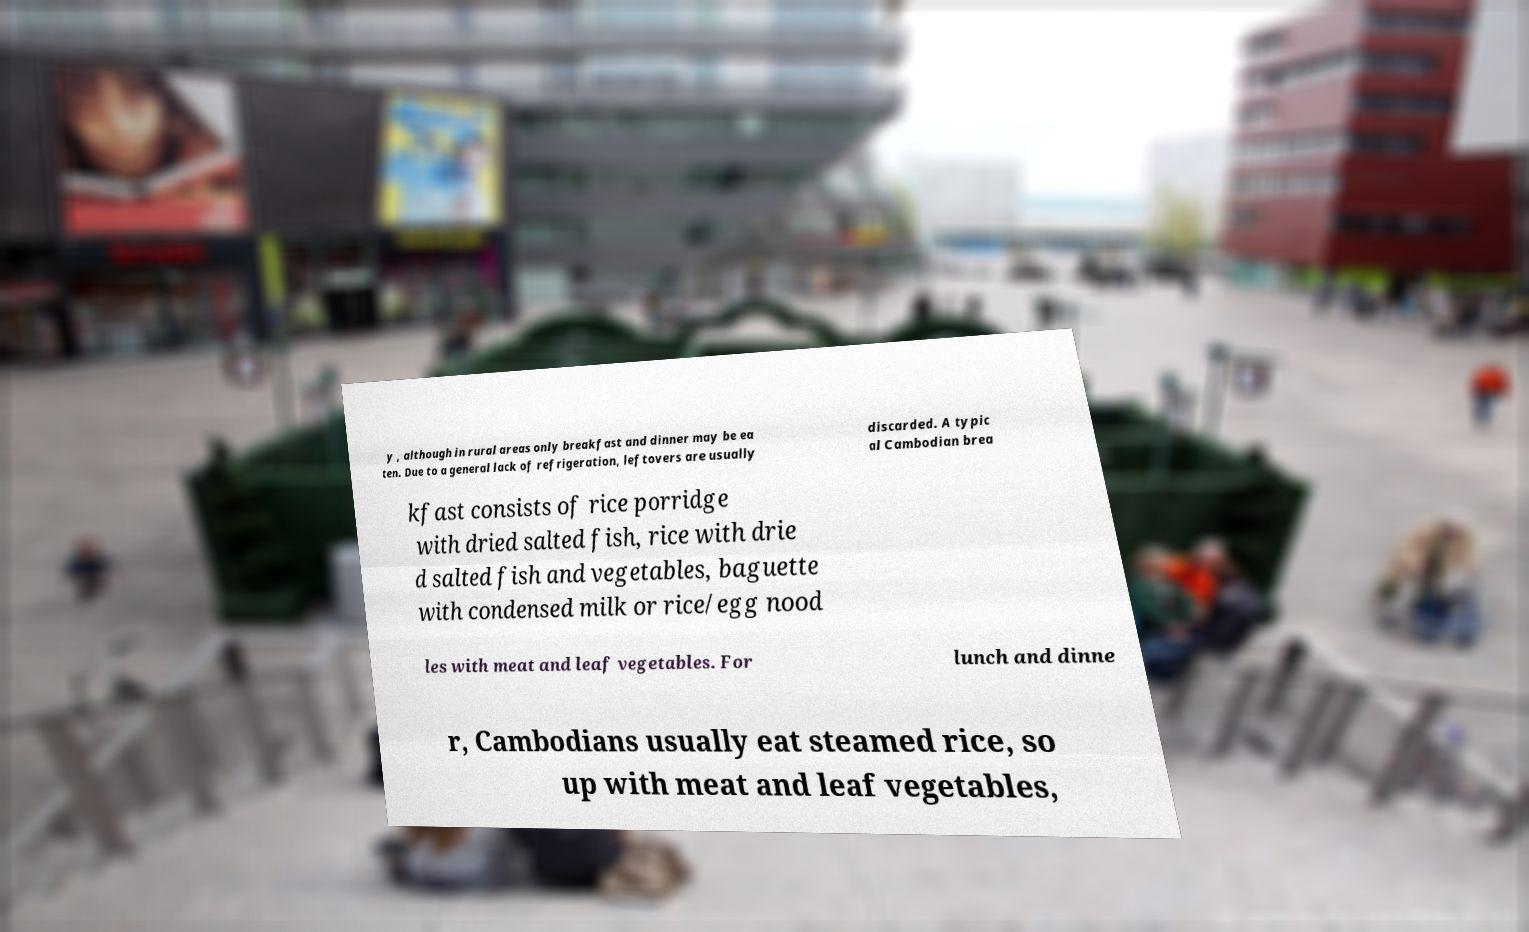What messages or text are displayed in this image? I need them in a readable, typed format. y , although in rural areas only breakfast and dinner may be ea ten. Due to a general lack of refrigeration, leftovers are usually discarded. A typic al Cambodian brea kfast consists of rice porridge with dried salted fish, rice with drie d salted fish and vegetables, baguette with condensed milk or rice/egg nood les with meat and leaf vegetables. For lunch and dinne r, Cambodians usually eat steamed rice, so up with meat and leaf vegetables, 